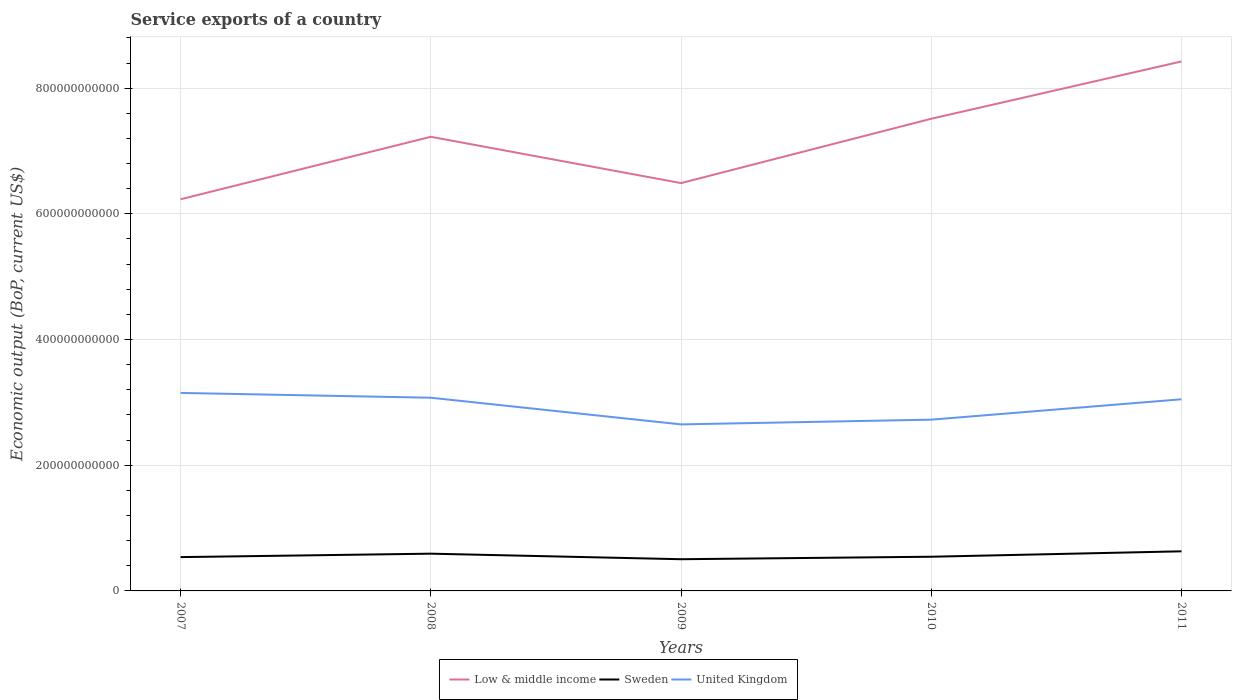How many different coloured lines are there?
Give a very brief answer. 3. Does the line corresponding to Low & middle income intersect with the line corresponding to Sweden?
Offer a very short reply. No. Across all years, what is the maximum service exports in Low & middle income?
Make the answer very short. 6.23e+11. In which year was the service exports in Sweden maximum?
Provide a short and direct response. 2009. What is the total service exports in Low & middle income in the graph?
Your response must be concise. -2.19e+11. What is the difference between the highest and the second highest service exports in United Kingdom?
Give a very brief answer. 5.01e+1. How many lines are there?
Offer a terse response. 3. What is the difference between two consecutive major ticks on the Y-axis?
Ensure brevity in your answer.  2.00e+11. Does the graph contain any zero values?
Make the answer very short. No. Where does the legend appear in the graph?
Provide a succinct answer. Bottom center. How many legend labels are there?
Make the answer very short. 3. What is the title of the graph?
Your response must be concise. Service exports of a country. Does "Mexico" appear as one of the legend labels in the graph?
Your answer should be very brief. No. What is the label or title of the Y-axis?
Provide a succinct answer. Economic output (BoP, current US$). What is the Economic output (BoP, current US$) in Low & middle income in 2007?
Give a very brief answer. 6.23e+11. What is the Economic output (BoP, current US$) in Sweden in 2007?
Offer a very short reply. 5.38e+1. What is the Economic output (BoP, current US$) of United Kingdom in 2007?
Provide a succinct answer. 3.15e+11. What is the Economic output (BoP, current US$) of Low & middle income in 2008?
Offer a very short reply. 7.23e+11. What is the Economic output (BoP, current US$) in Sweden in 2008?
Offer a very short reply. 5.93e+1. What is the Economic output (BoP, current US$) of United Kingdom in 2008?
Provide a short and direct response. 3.07e+11. What is the Economic output (BoP, current US$) in Low & middle income in 2009?
Your response must be concise. 6.49e+11. What is the Economic output (BoP, current US$) of Sweden in 2009?
Your answer should be compact. 5.05e+1. What is the Economic output (BoP, current US$) in United Kingdom in 2009?
Ensure brevity in your answer.  2.65e+11. What is the Economic output (BoP, current US$) of Low & middle income in 2010?
Offer a very short reply. 7.51e+11. What is the Economic output (BoP, current US$) in Sweden in 2010?
Ensure brevity in your answer.  5.44e+1. What is the Economic output (BoP, current US$) in United Kingdom in 2010?
Offer a very short reply. 2.73e+11. What is the Economic output (BoP, current US$) in Low & middle income in 2011?
Ensure brevity in your answer.  8.42e+11. What is the Economic output (BoP, current US$) of Sweden in 2011?
Keep it short and to the point. 6.30e+1. What is the Economic output (BoP, current US$) of United Kingdom in 2011?
Your answer should be compact. 3.05e+11. Across all years, what is the maximum Economic output (BoP, current US$) in Low & middle income?
Keep it short and to the point. 8.42e+11. Across all years, what is the maximum Economic output (BoP, current US$) of Sweden?
Your answer should be very brief. 6.30e+1. Across all years, what is the maximum Economic output (BoP, current US$) in United Kingdom?
Provide a short and direct response. 3.15e+11. Across all years, what is the minimum Economic output (BoP, current US$) in Low & middle income?
Ensure brevity in your answer.  6.23e+11. Across all years, what is the minimum Economic output (BoP, current US$) in Sweden?
Your response must be concise. 5.05e+1. Across all years, what is the minimum Economic output (BoP, current US$) in United Kingdom?
Your answer should be very brief. 2.65e+11. What is the total Economic output (BoP, current US$) in Low & middle income in the graph?
Keep it short and to the point. 3.59e+12. What is the total Economic output (BoP, current US$) in Sweden in the graph?
Your answer should be compact. 2.81e+11. What is the total Economic output (BoP, current US$) of United Kingdom in the graph?
Your answer should be compact. 1.46e+12. What is the difference between the Economic output (BoP, current US$) of Low & middle income in 2007 and that in 2008?
Your response must be concise. -9.95e+1. What is the difference between the Economic output (BoP, current US$) in Sweden in 2007 and that in 2008?
Keep it short and to the point. -5.47e+09. What is the difference between the Economic output (BoP, current US$) of United Kingdom in 2007 and that in 2008?
Ensure brevity in your answer.  7.64e+09. What is the difference between the Economic output (BoP, current US$) of Low & middle income in 2007 and that in 2009?
Your response must be concise. -2.58e+1. What is the difference between the Economic output (BoP, current US$) in Sweden in 2007 and that in 2009?
Ensure brevity in your answer.  3.34e+09. What is the difference between the Economic output (BoP, current US$) in United Kingdom in 2007 and that in 2009?
Provide a succinct answer. 5.01e+1. What is the difference between the Economic output (BoP, current US$) in Low & middle income in 2007 and that in 2010?
Provide a succinct answer. -1.28e+11. What is the difference between the Economic output (BoP, current US$) in Sweden in 2007 and that in 2010?
Offer a very short reply. -6.12e+08. What is the difference between the Economic output (BoP, current US$) in United Kingdom in 2007 and that in 2010?
Your answer should be very brief. 4.26e+1. What is the difference between the Economic output (BoP, current US$) in Low & middle income in 2007 and that in 2011?
Keep it short and to the point. -2.19e+11. What is the difference between the Economic output (BoP, current US$) of Sweden in 2007 and that in 2011?
Make the answer very short. -9.23e+09. What is the difference between the Economic output (BoP, current US$) of United Kingdom in 2007 and that in 2011?
Your answer should be compact. 1.01e+1. What is the difference between the Economic output (BoP, current US$) in Low & middle income in 2008 and that in 2009?
Offer a very short reply. 7.37e+1. What is the difference between the Economic output (BoP, current US$) of Sweden in 2008 and that in 2009?
Your answer should be very brief. 8.81e+09. What is the difference between the Economic output (BoP, current US$) of United Kingdom in 2008 and that in 2009?
Ensure brevity in your answer.  4.24e+1. What is the difference between the Economic output (BoP, current US$) in Low & middle income in 2008 and that in 2010?
Make the answer very short. -2.87e+1. What is the difference between the Economic output (BoP, current US$) in Sweden in 2008 and that in 2010?
Your response must be concise. 4.86e+09. What is the difference between the Economic output (BoP, current US$) of United Kingdom in 2008 and that in 2010?
Your answer should be compact. 3.49e+1. What is the difference between the Economic output (BoP, current US$) in Low & middle income in 2008 and that in 2011?
Keep it short and to the point. -1.20e+11. What is the difference between the Economic output (BoP, current US$) in Sweden in 2008 and that in 2011?
Provide a short and direct response. -3.76e+09. What is the difference between the Economic output (BoP, current US$) of United Kingdom in 2008 and that in 2011?
Make the answer very short. 2.47e+09. What is the difference between the Economic output (BoP, current US$) of Low & middle income in 2009 and that in 2010?
Your answer should be very brief. -1.02e+11. What is the difference between the Economic output (BoP, current US$) of Sweden in 2009 and that in 2010?
Provide a succinct answer. -3.95e+09. What is the difference between the Economic output (BoP, current US$) in United Kingdom in 2009 and that in 2010?
Provide a succinct answer. -7.52e+09. What is the difference between the Economic output (BoP, current US$) of Low & middle income in 2009 and that in 2011?
Provide a succinct answer. -1.94e+11. What is the difference between the Economic output (BoP, current US$) in Sweden in 2009 and that in 2011?
Keep it short and to the point. -1.26e+1. What is the difference between the Economic output (BoP, current US$) of United Kingdom in 2009 and that in 2011?
Give a very brief answer. -4.00e+1. What is the difference between the Economic output (BoP, current US$) of Low & middle income in 2010 and that in 2011?
Provide a succinct answer. -9.12e+1. What is the difference between the Economic output (BoP, current US$) in Sweden in 2010 and that in 2011?
Provide a short and direct response. -8.62e+09. What is the difference between the Economic output (BoP, current US$) in United Kingdom in 2010 and that in 2011?
Your answer should be very brief. -3.24e+1. What is the difference between the Economic output (BoP, current US$) of Low & middle income in 2007 and the Economic output (BoP, current US$) of Sweden in 2008?
Give a very brief answer. 5.64e+11. What is the difference between the Economic output (BoP, current US$) in Low & middle income in 2007 and the Economic output (BoP, current US$) in United Kingdom in 2008?
Your answer should be very brief. 3.16e+11. What is the difference between the Economic output (BoP, current US$) in Sweden in 2007 and the Economic output (BoP, current US$) in United Kingdom in 2008?
Your answer should be compact. -2.54e+11. What is the difference between the Economic output (BoP, current US$) in Low & middle income in 2007 and the Economic output (BoP, current US$) in Sweden in 2009?
Offer a terse response. 5.73e+11. What is the difference between the Economic output (BoP, current US$) in Low & middle income in 2007 and the Economic output (BoP, current US$) in United Kingdom in 2009?
Your answer should be very brief. 3.58e+11. What is the difference between the Economic output (BoP, current US$) in Sweden in 2007 and the Economic output (BoP, current US$) in United Kingdom in 2009?
Offer a very short reply. -2.11e+11. What is the difference between the Economic output (BoP, current US$) in Low & middle income in 2007 and the Economic output (BoP, current US$) in Sweden in 2010?
Your answer should be very brief. 5.69e+11. What is the difference between the Economic output (BoP, current US$) in Low & middle income in 2007 and the Economic output (BoP, current US$) in United Kingdom in 2010?
Offer a very short reply. 3.51e+11. What is the difference between the Economic output (BoP, current US$) of Sweden in 2007 and the Economic output (BoP, current US$) of United Kingdom in 2010?
Make the answer very short. -2.19e+11. What is the difference between the Economic output (BoP, current US$) in Low & middle income in 2007 and the Economic output (BoP, current US$) in Sweden in 2011?
Your answer should be very brief. 5.60e+11. What is the difference between the Economic output (BoP, current US$) in Low & middle income in 2007 and the Economic output (BoP, current US$) in United Kingdom in 2011?
Ensure brevity in your answer.  3.18e+11. What is the difference between the Economic output (BoP, current US$) in Sweden in 2007 and the Economic output (BoP, current US$) in United Kingdom in 2011?
Your answer should be very brief. -2.51e+11. What is the difference between the Economic output (BoP, current US$) of Low & middle income in 2008 and the Economic output (BoP, current US$) of Sweden in 2009?
Provide a short and direct response. 6.72e+11. What is the difference between the Economic output (BoP, current US$) in Low & middle income in 2008 and the Economic output (BoP, current US$) in United Kingdom in 2009?
Offer a very short reply. 4.58e+11. What is the difference between the Economic output (BoP, current US$) of Sweden in 2008 and the Economic output (BoP, current US$) of United Kingdom in 2009?
Give a very brief answer. -2.06e+11. What is the difference between the Economic output (BoP, current US$) of Low & middle income in 2008 and the Economic output (BoP, current US$) of Sweden in 2010?
Give a very brief answer. 6.68e+11. What is the difference between the Economic output (BoP, current US$) of Low & middle income in 2008 and the Economic output (BoP, current US$) of United Kingdom in 2010?
Your response must be concise. 4.50e+11. What is the difference between the Economic output (BoP, current US$) of Sweden in 2008 and the Economic output (BoP, current US$) of United Kingdom in 2010?
Provide a succinct answer. -2.13e+11. What is the difference between the Economic output (BoP, current US$) in Low & middle income in 2008 and the Economic output (BoP, current US$) in Sweden in 2011?
Your answer should be compact. 6.60e+11. What is the difference between the Economic output (BoP, current US$) in Low & middle income in 2008 and the Economic output (BoP, current US$) in United Kingdom in 2011?
Offer a terse response. 4.18e+11. What is the difference between the Economic output (BoP, current US$) of Sweden in 2008 and the Economic output (BoP, current US$) of United Kingdom in 2011?
Ensure brevity in your answer.  -2.46e+11. What is the difference between the Economic output (BoP, current US$) in Low & middle income in 2009 and the Economic output (BoP, current US$) in Sweden in 2010?
Make the answer very short. 5.95e+11. What is the difference between the Economic output (BoP, current US$) of Low & middle income in 2009 and the Economic output (BoP, current US$) of United Kingdom in 2010?
Make the answer very short. 3.76e+11. What is the difference between the Economic output (BoP, current US$) of Sweden in 2009 and the Economic output (BoP, current US$) of United Kingdom in 2010?
Provide a short and direct response. -2.22e+11. What is the difference between the Economic output (BoP, current US$) in Low & middle income in 2009 and the Economic output (BoP, current US$) in Sweden in 2011?
Offer a very short reply. 5.86e+11. What is the difference between the Economic output (BoP, current US$) of Low & middle income in 2009 and the Economic output (BoP, current US$) of United Kingdom in 2011?
Make the answer very short. 3.44e+11. What is the difference between the Economic output (BoP, current US$) in Sweden in 2009 and the Economic output (BoP, current US$) in United Kingdom in 2011?
Provide a short and direct response. -2.54e+11. What is the difference between the Economic output (BoP, current US$) of Low & middle income in 2010 and the Economic output (BoP, current US$) of Sweden in 2011?
Your answer should be very brief. 6.88e+11. What is the difference between the Economic output (BoP, current US$) in Low & middle income in 2010 and the Economic output (BoP, current US$) in United Kingdom in 2011?
Offer a terse response. 4.46e+11. What is the difference between the Economic output (BoP, current US$) in Sweden in 2010 and the Economic output (BoP, current US$) in United Kingdom in 2011?
Your response must be concise. -2.51e+11. What is the average Economic output (BoP, current US$) of Low & middle income per year?
Your response must be concise. 7.18e+11. What is the average Economic output (BoP, current US$) of Sweden per year?
Give a very brief answer. 5.62e+1. What is the average Economic output (BoP, current US$) of United Kingdom per year?
Offer a very short reply. 2.93e+11. In the year 2007, what is the difference between the Economic output (BoP, current US$) of Low & middle income and Economic output (BoP, current US$) of Sweden?
Provide a succinct answer. 5.69e+11. In the year 2007, what is the difference between the Economic output (BoP, current US$) of Low & middle income and Economic output (BoP, current US$) of United Kingdom?
Your answer should be compact. 3.08e+11. In the year 2007, what is the difference between the Economic output (BoP, current US$) of Sweden and Economic output (BoP, current US$) of United Kingdom?
Give a very brief answer. -2.61e+11. In the year 2008, what is the difference between the Economic output (BoP, current US$) in Low & middle income and Economic output (BoP, current US$) in Sweden?
Your response must be concise. 6.63e+11. In the year 2008, what is the difference between the Economic output (BoP, current US$) of Low & middle income and Economic output (BoP, current US$) of United Kingdom?
Give a very brief answer. 4.15e+11. In the year 2008, what is the difference between the Economic output (BoP, current US$) in Sweden and Economic output (BoP, current US$) in United Kingdom?
Your response must be concise. -2.48e+11. In the year 2009, what is the difference between the Economic output (BoP, current US$) in Low & middle income and Economic output (BoP, current US$) in Sweden?
Your answer should be very brief. 5.98e+11. In the year 2009, what is the difference between the Economic output (BoP, current US$) of Low & middle income and Economic output (BoP, current US$) of United Kingdom?
Your answer should be very brief. 3.84e+11. In the year 2009, what is the difference between the Economic output (BoP, current US$) of Sweden and Economic output (BoP, current US$) of United Kingdom?
Offer a very short reply. -2.15e+11. In the year 2010, what is the difference between the Economic output (BoP, current US$) of Low & middle income and Economic output (BoP, current US$) of Sweden?
Provide a succinct answer. 6.97e+11. In the year 2010, what is the difference between the Economic output (BoP, current US$) in Low & middle income and Economic output (BoP, current US$) in United Kingdom?
Your answer should be compact. 4.79e+11. In the year 2010, what is the difference between the Economic output (BoP, current US$) of Sweden and Economic output (BoP, current US$) of United Kingdom?
Give a very brief answer. -2.18e+11. In the year 2011, what is the difference between the Economic output (BoP, current US$) of Low & middle income and Economic output (BoP, current US$) of Sweden?
Offer a very short reply. 7.79e+11. In the year 2011, what is the difference between the Economic output (BoP, current US$) in Low & middle income and Economic output (BoP, current US$) in United Kingdom?
Offer a terse response. 5.38e+11. In the year 2011, what is the difference between the Economic output (BoP, current US$) of Sweden and Economic output (BoP, current US$) of United Kingdom?
Provide a succinct answer. -2.42e+11. What is the ratio of the Economic output (BoP, current US$) of Low & middle income in 2007 to that in 2008?
Your response must be concise. 0.86. What is the ratio of the Economic output (BoP, current US$) of Sweden in 2007 to that in 2008?
Your answer should be very brief. 0.91. What is the ratio of the Economic output (BoP, current US$) in United Kingdom in 2007 to that in 2008?
Ensure brevity in your answer.  1.02. What is the ratio of the Economic output (BoP, current US$) of Low & middle income in 2007 to that in 2009?
Make the answer very short. 0.96. What is the ratio of the Economic output (BoP, current US$) in Sweden in 2007 to that in 2009?
Your answer should be compact. 1.07. What is the ratio of the Economic output (BoP, current US$) in United Kingdom in 2007 to that in 2009?
Give a very brief answer. 1.19. What is the ratio of the Economic output (BoP, current US$) in Low & middle income in 2007 to that in 2010?
Offer a terse response. 0.83. What is the ratio of the Economic output (BoP, current US$) of Sweden in 2007 to that in 2010?
Offer a very short reply. 0.99. What is the ratio of the Economic output (BoP, current US$) of United Kingdom in 2007 to that in 2010?
Provide a succinct answer. 1.16. What is the ratio of the Economic output (BoP, current US$) in Low & middle income in 2007 to that in 2011?
Provide a succinct answer. 0.74. What is the ratio of the Economic output (BoP, current US$) of Sweden in 2007 to that in 2011?
Provide a succinct answer. 0.85. What is the ratio of the Economic output (BoP, current US$) in United Kingdom in 2007 to that in 2011?
Ensure brevity in your answer.  1.03. What is the ratio of the Economic output (BoP, current US$) of Low & middle income in 2008 to that in 2009?
Give a very brief answer. 1.11. What is the ratio of the Economic output (BoP, current US$) in Sweden in 2008 to that in 2009?
Provide a short and direct response. 1.17. What is the ratio of the Economic output (BoP, current US$) of United Kingdom in 2008 to that in 2009?
Offer a terse response. 1.16. What is the ratio of the Economic output (BoP, current US$) of Low & middle income in 2008 to that in 2010?
Keep it short and to the point. 0.96. What is the ratio of the Economic output (BoP, current US$) of Sweden in 2008 to that in 2010?
Give a very brief answer. 1.09. What is the ratio of the Economic output (BoP, current US$) in United Kingdom in 2008 to that in 2010?
Provide a short and direct response. 1.13. What is the ratio of the Economic output (BoP, current US$) in Low & middle income in 2008 to that in 2011?
Make the answer very short. 0.86. What is the ratio of the Economic output (BoP, current US$) of Sweden in 2008 to that in 2011?
Provide a succinct answer. 0.94. What is the ratio of the Economic output (BoP, current US$) of Low & middle income in 2009 to that in 2010?
Your answer should be compact. 0.86. What is the ratio of the Economic output (BoP, current US$) in Sweden in 2009 to that in 2010?
Provide a short and direct response. 0.93. What is the ratio of the Economic output (BoP, current US$) in United Kingdom in 2009 to that in 2010?
Make the answer very short. 0.97. What is the ratio of the Economic output (BoP, current US$) in Low & middle income in 2009 to that in 2011?
Offer a terse response. 0.77. What is the ratio of the Economic output (BoP, current US$) in Sweden in 2009 to that in 2011?
Make the answer very short. 0.8. What is the ratio of the Economic output (BoP, current US$) in United Kingdom in 2009 to that in 2011?
Your response must be concise. 0.87. What is the ratio of the Economic output (BoP, current US$) in Low & middle income in 2010 to that in 2011?
Your answer should be compact. 0.89. What is the ratio of the Economic output (BoP, current US$) of Sweden in 2010 to that in 2011?
Provide a short and direct response. 0.86. What is the ratio of the Economic output (BoP, current US$) of United Kingdom in 2010 to that in 2011?
Offer a terse response. 0.89. What is the difference between the highest and the second highest Economic output (BoP, current US$) of Low & middle income?
Your answer should be compact. 9.12e+1. What is the difference between the highest and the second highest Economic output (BoP, current US$) of Sweden?
Provide a short and direct response. 3.76e+09. What is the difference between the highest and the second highest Economic output (BoP, current US$) of United Kingdom?
Offer a very short reply. 7.64e+09. What is the difference between the highest and the lowest Economic output (BoP, current US$) in Low & middle income?
Offer a terse response. 2.19e+11. What is the difference between the highest and the lowest Economic output (BoP, current US$) in Sweden?
Provide a succinct answer. 1.26e+1. What is the difference between the highest and the lowest Economic output (BoP, current US$) in United Kingdom?
Give a very brief answer. 5.01e+1. 